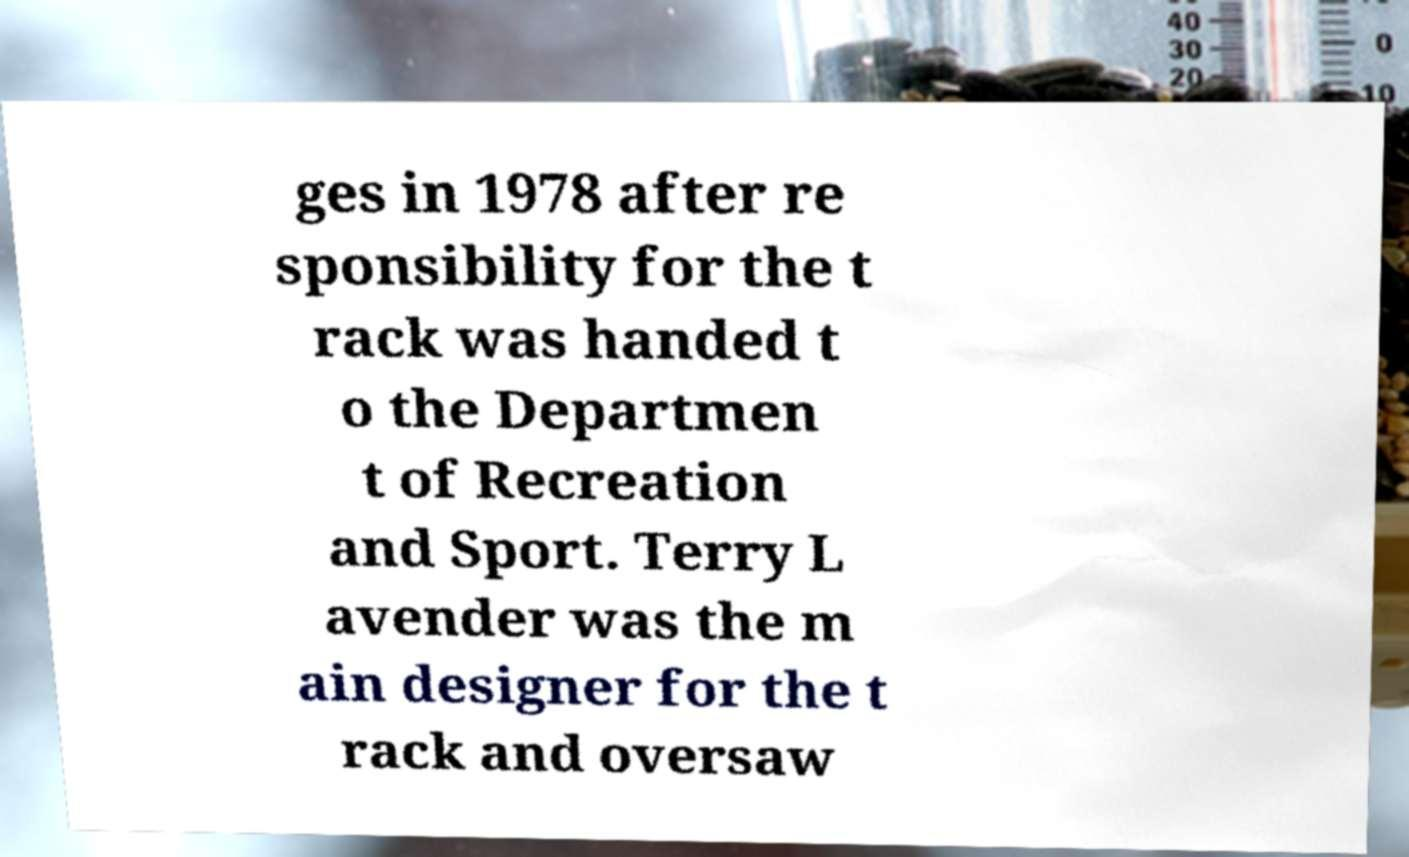Please identify and transcribe the text found in this image. ges in 1978 after re sponsibility for the t rack was handed t o the Departmen t of Recreation and Sport. Terry L avender was the m ain designer for the t rack and oversaw 